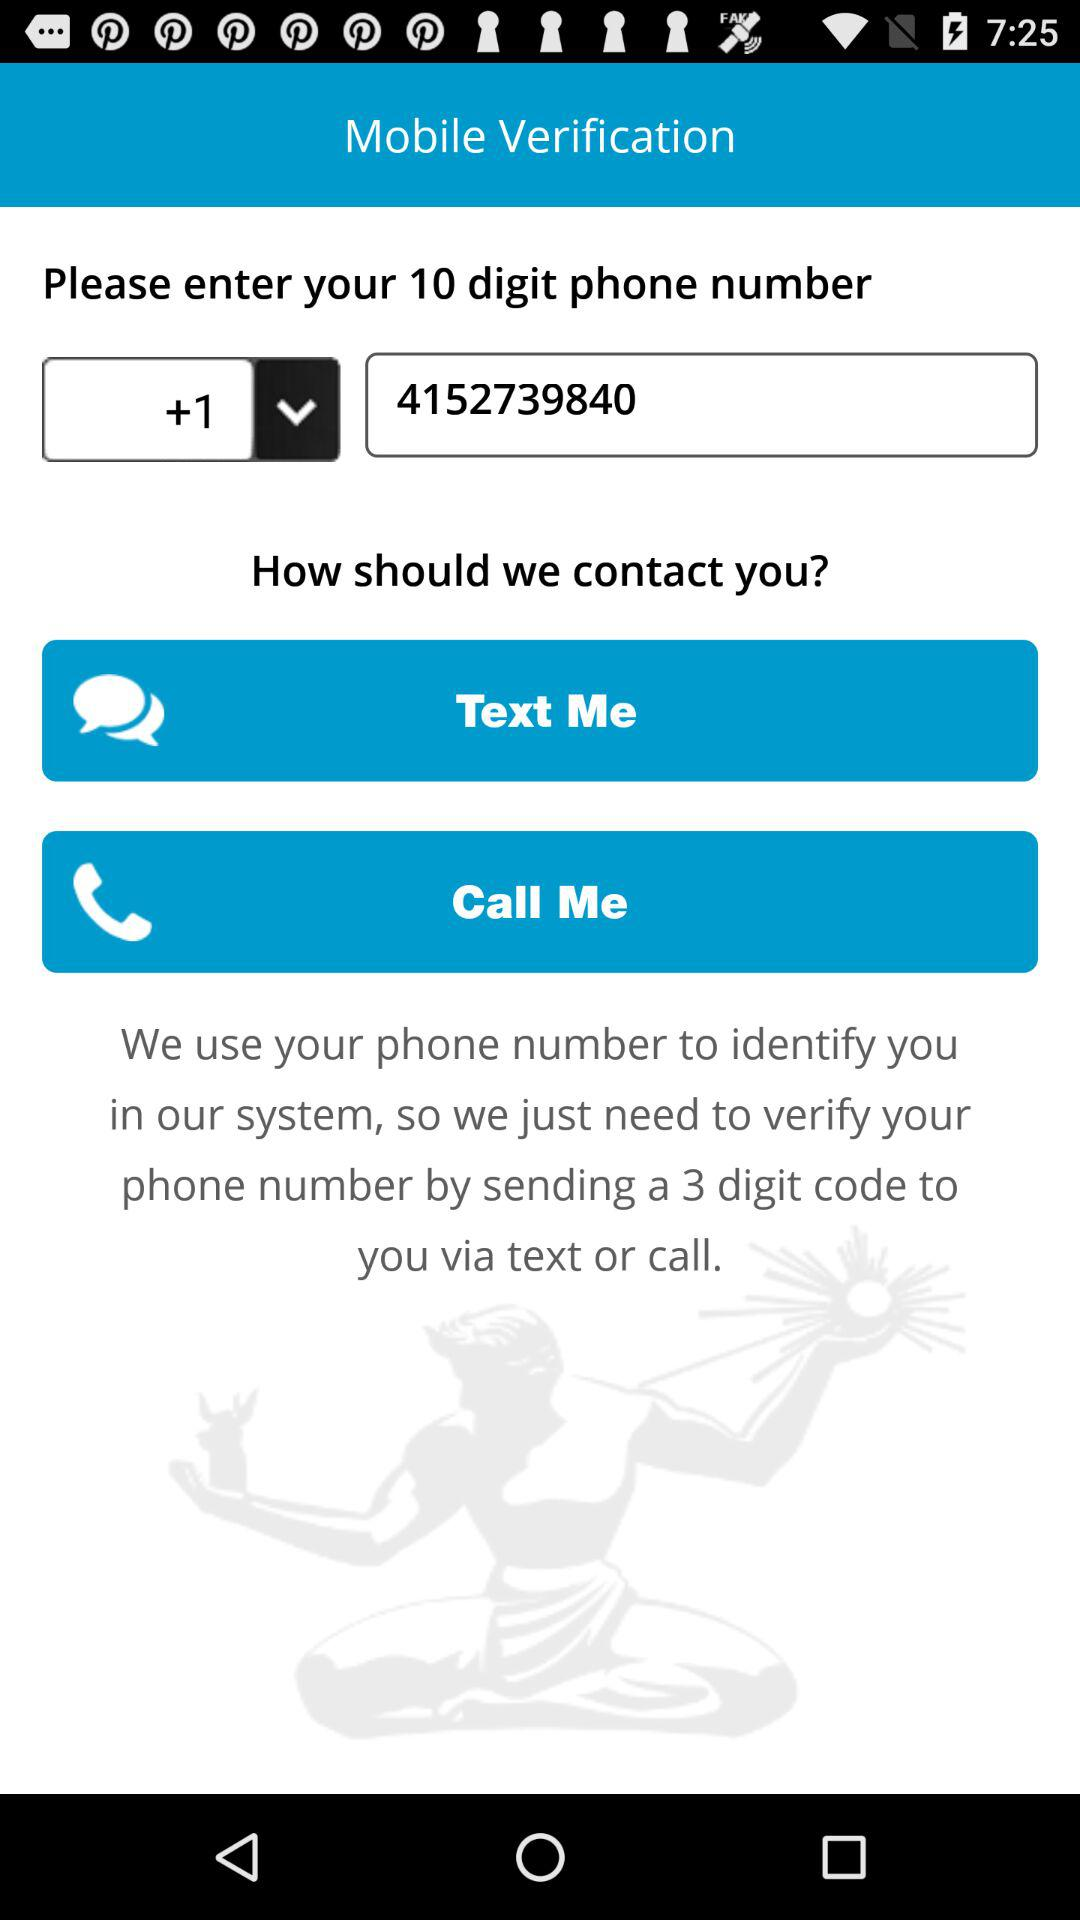How many digits are in the phone number that is displayed?
Answer the question using a single word or phrase. 10 